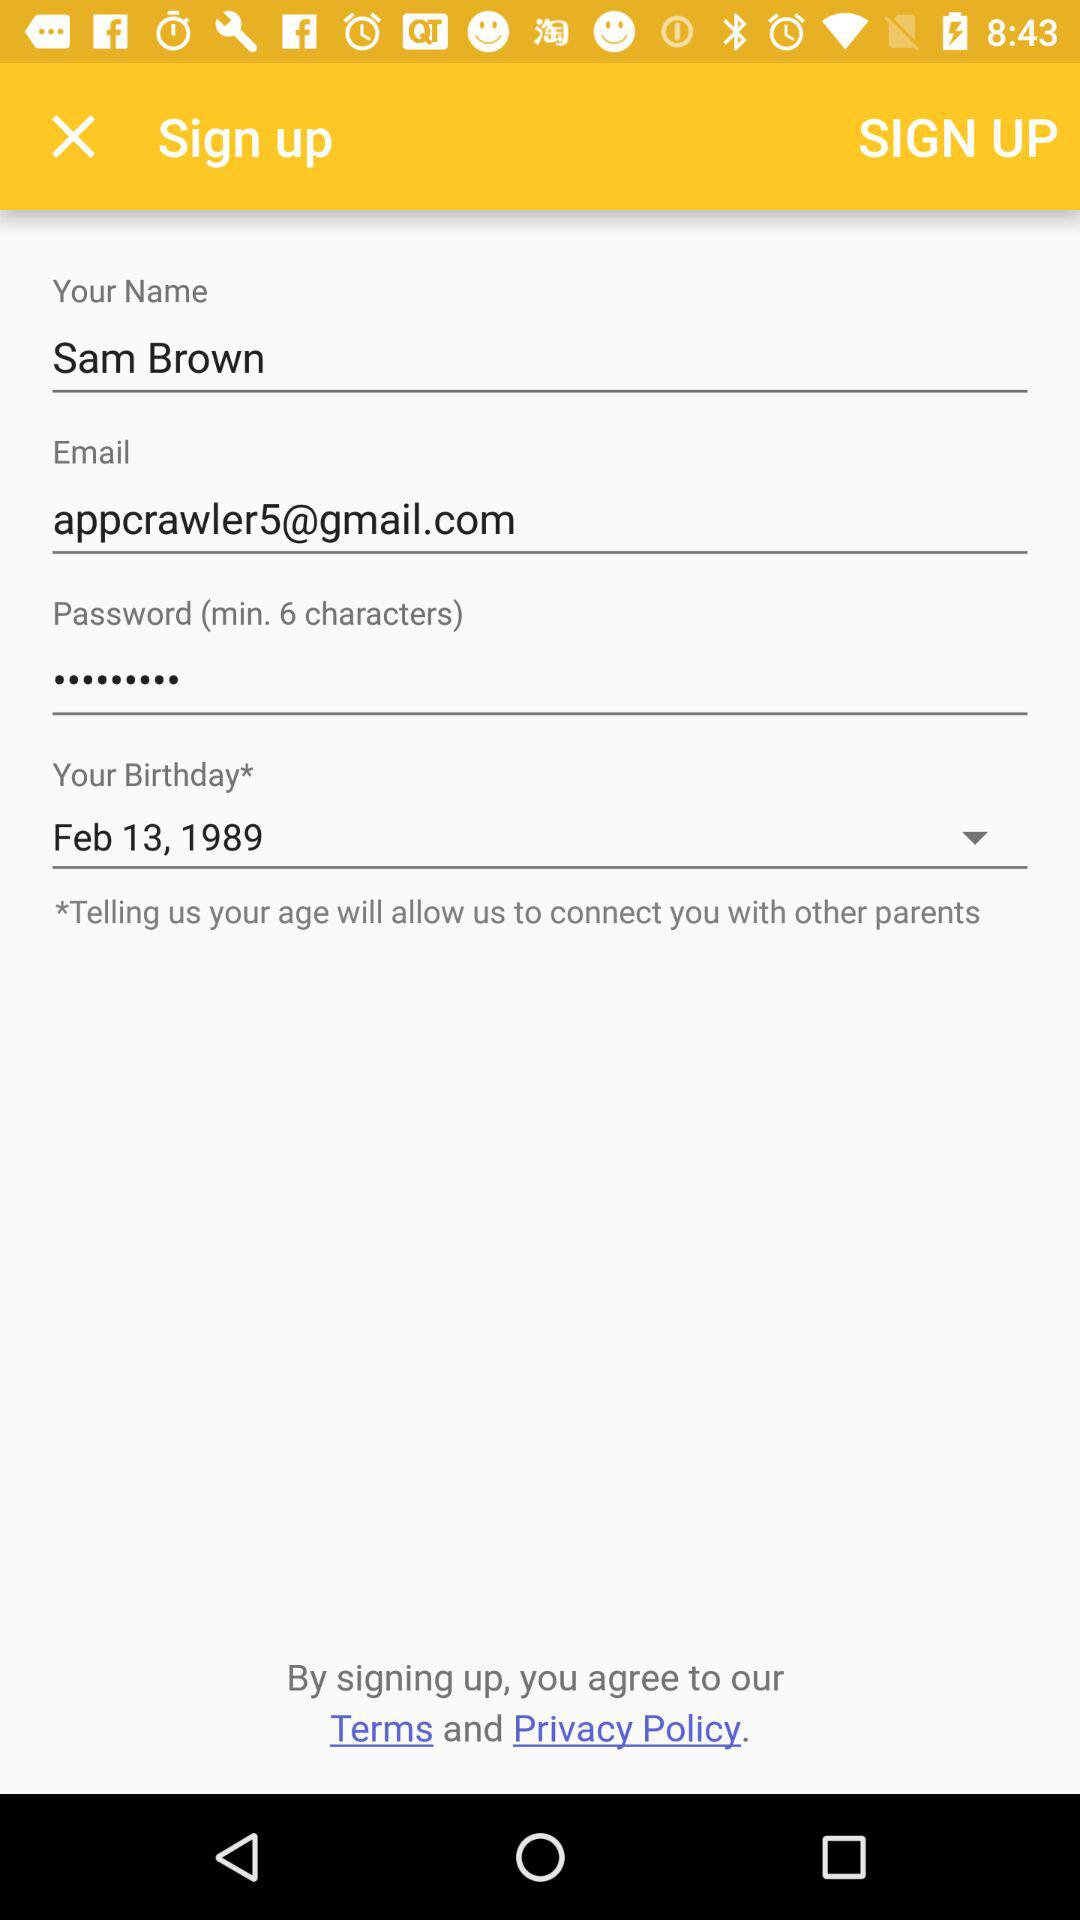How many minimum characters are required to create a password? A password must have a minimum of 6 characters. 